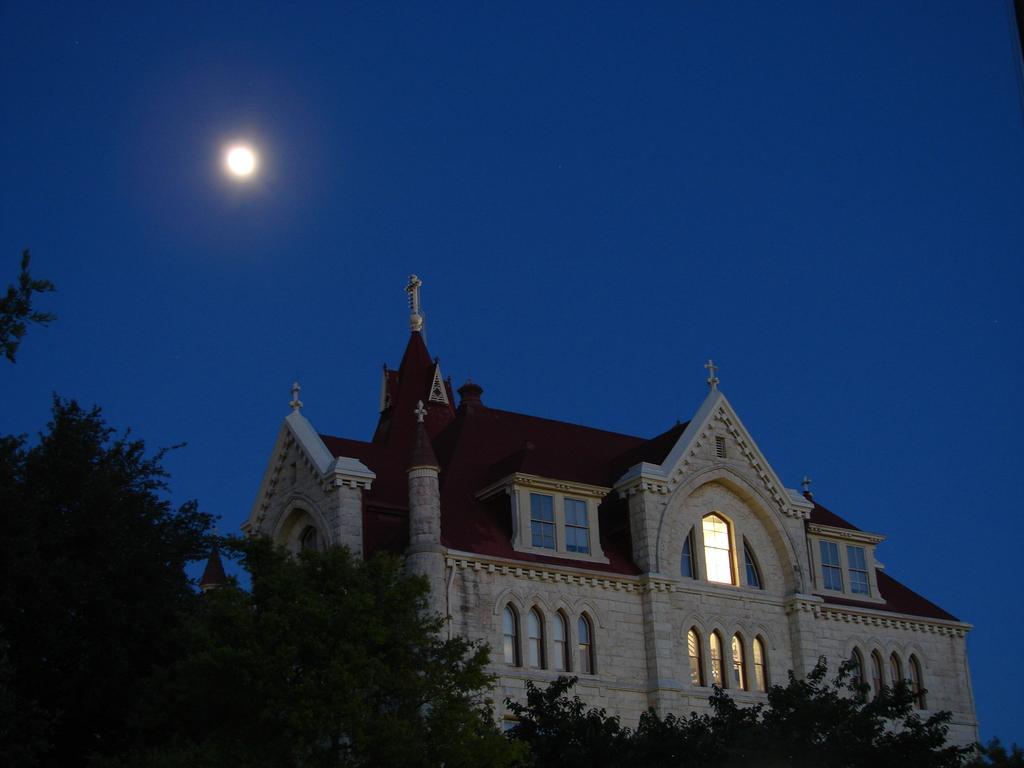Can you describe this image briefly? In the foreground of the picture there are trees and a cathedral. In the sky it is moon. 